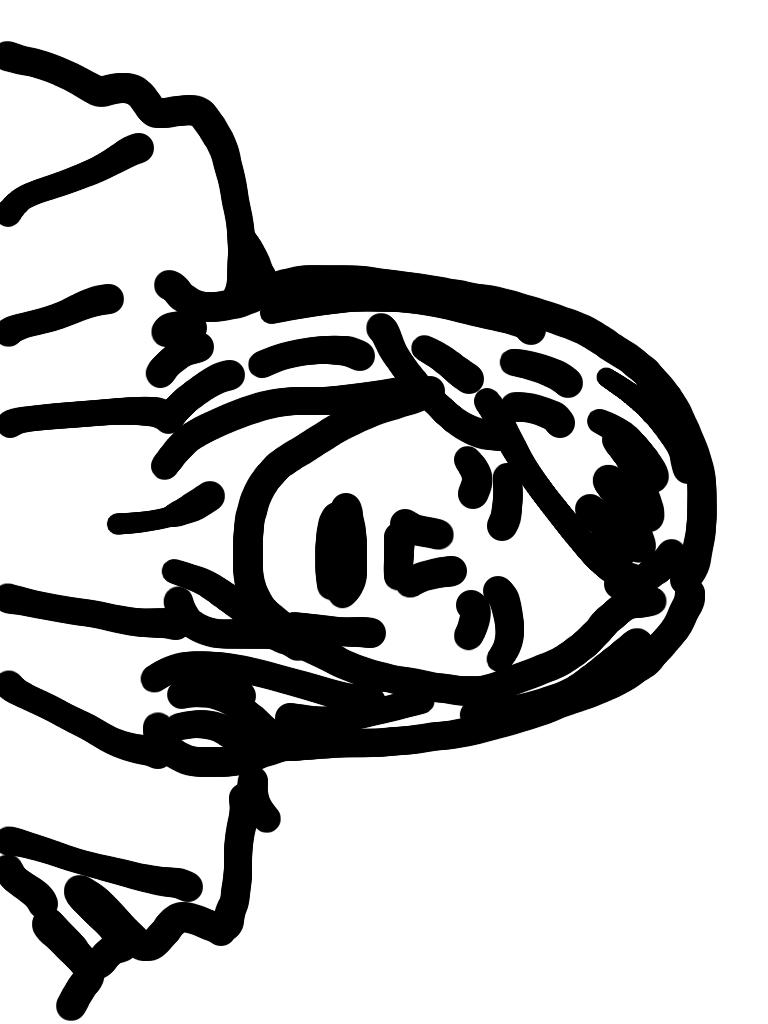What is the main subject of the image? There is a depiction of a woman in the center of the image. What type of horn is attached to the roof of the building in the image? There is no building or horn present in the image; it features a depiction of a woman. How does the drain system work in the image? There is no drain system present in the image; it features a depiction of a woman. 